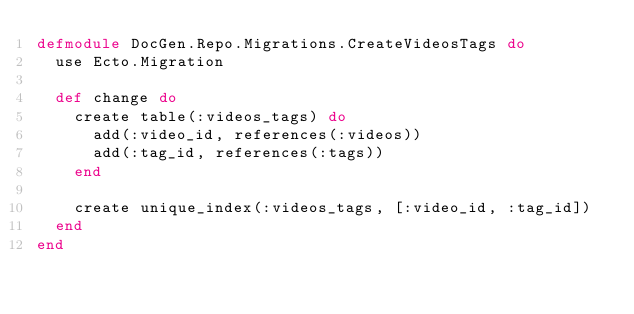Convert code to text. <code><loc_0><loc_0><loc_500><loc_500><_Elixir_>defmodule DocGen.Repo.Migrations.CreateVideosTags do
  use Ecto.Migration

  def change do
    create table(:videos_tags) do
      add(:video_id, references(:videos))
      add(:tag_id, references(:tags))
    end

    create unique_index(:videos_tags, [:video_id, :tag_id])
  end
end
</code> 